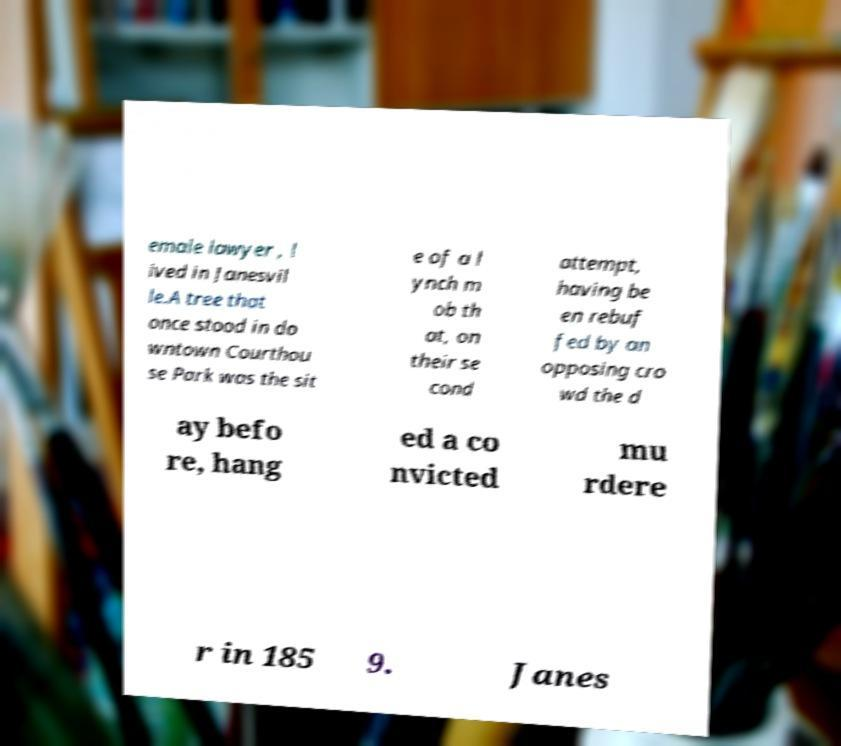Can you read and provide the text displayed in the image?This photo seems to have some interesting text. Can you extract and type it out for me? emale lawyer , l ived in Janesvil le.A tree that once stood in do wntown Courthou se Park was the sit e of a l ynch m ob th at, on their se cond attempt, having be en rebuf fed by an opposing cro wd the d ay befo re, hang ed a co nvicted mu rdere r in 185 9. Janes 